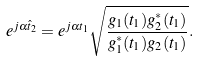<formula> <loc_0><loc_0><loc_500><loc_500>e ^ { j \alpha \hat { t } _ { 2 } } = e ^ { j \alpha { t } _ { 1 } } \sqrt { \frac { g _ { 1 } ( t _ { 1 } ) g ^ { * } _ { 2 } ( t _ { 1 } ) } { g ^ { * } _ { 1 } ( t _ { 1 } ) g _ { 2 } ( t _ { 1 } ) } } .</formula> 